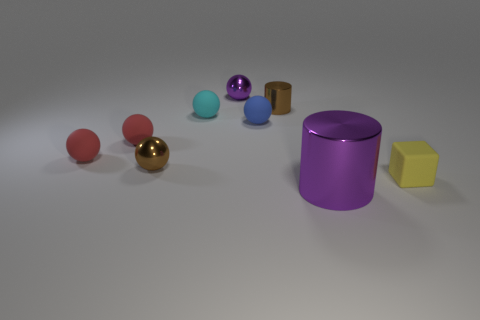Are the objects on the table organized in a specific pattern? The arrangement of the objects on the surface does not follow a strict pattern but seems to be laid out in a loose arc or curve, with varying distances between each item. 